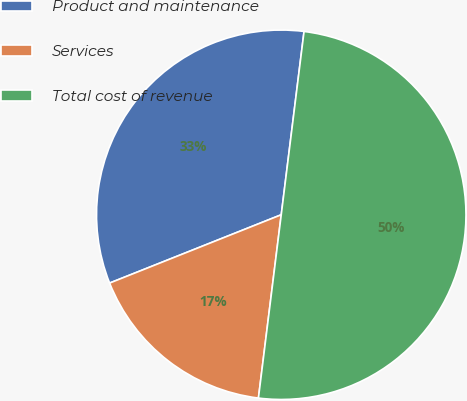Convert chart to OTSL. <chart><loc_0><loc_0><loc_500><loc_500><pie_chart><fcel>Product and maintenance<fcel>Services<fcel>Total cost of revenue<nl><fcel>33.0%<fcel>17.0%<fcel>50.0%<nl></chart> 